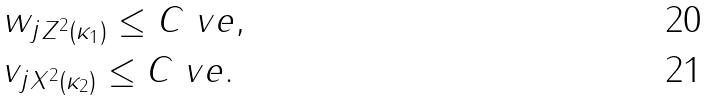Convert formula to latex. <formula><loc_0><loc_0><loc_500><loc_500>& \| w _ { j } \| _ { Z ^ { 2 } ( \kappa _ { 1 } ) } \leq C \ v e , \\ & \| v _ { j } \| _ { X ^ { 2 } ( \kappa _ { 2 } ) } \leq C \ v e .</formula> 